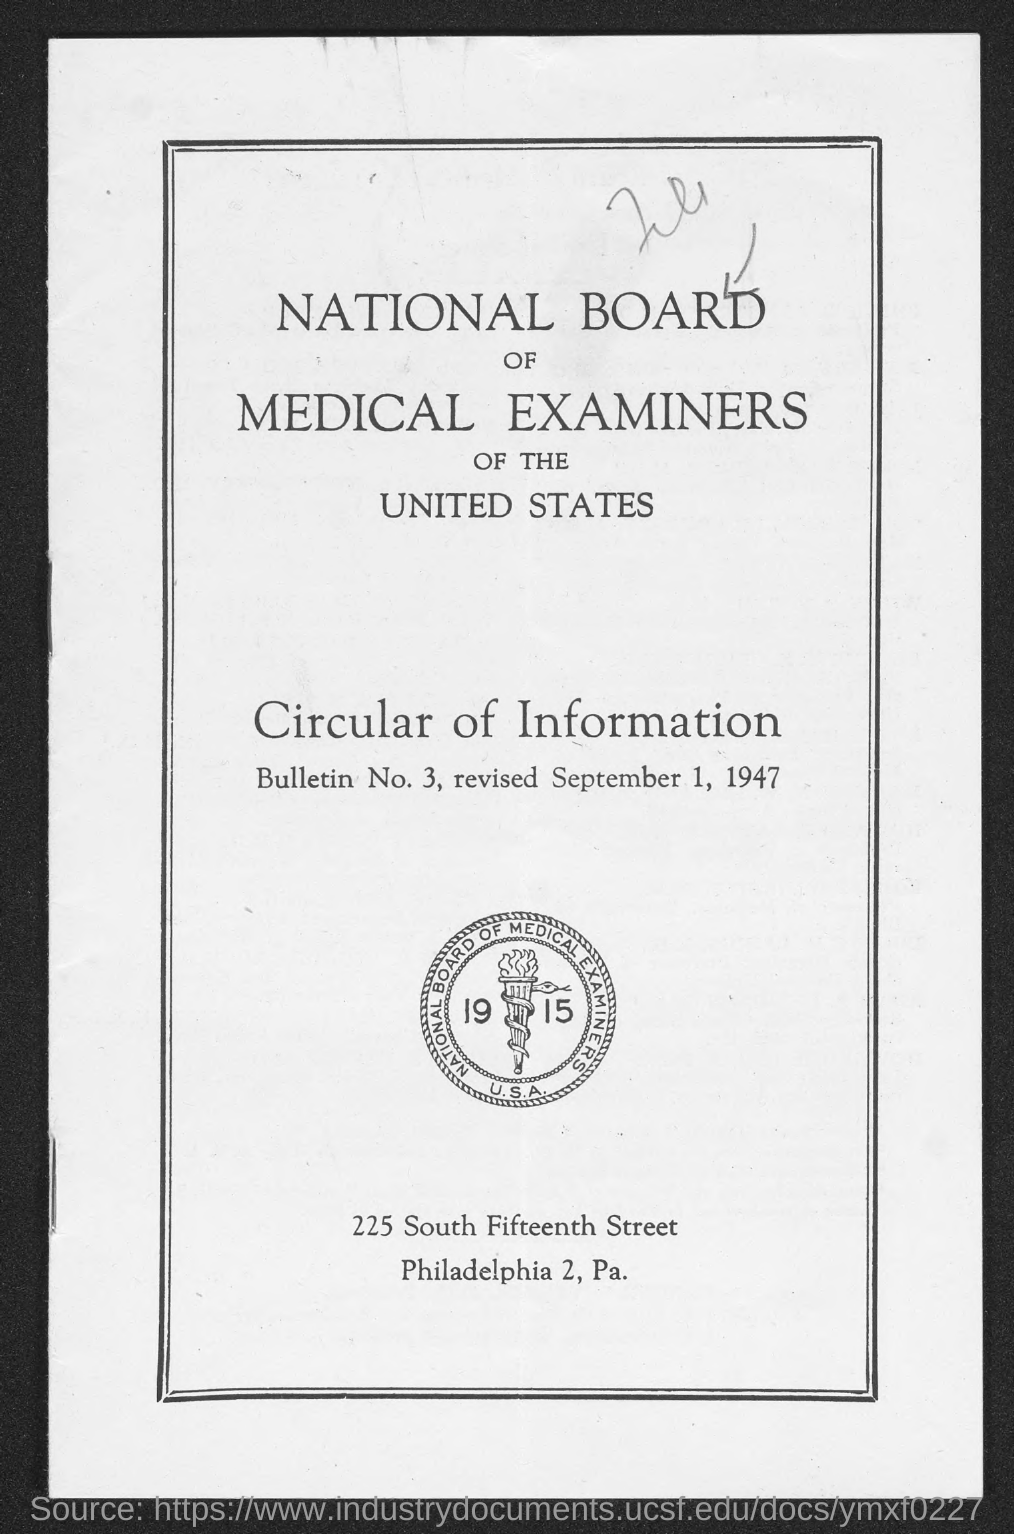Point out several critical features in this image. The National Board of Medical Examiners of the United States is a board mentioned in the given page. The bulletin number mentioned on the given page is 3. The revised date mentioned on the given page is September 1, 1947. 